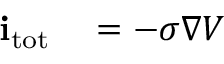<formula> <loc_0><loc_0><loc_500><loc_500>\begin{array} { r l } { i _ { t o t } } & = - \sigma \nabla V } \end{array}</formula> 